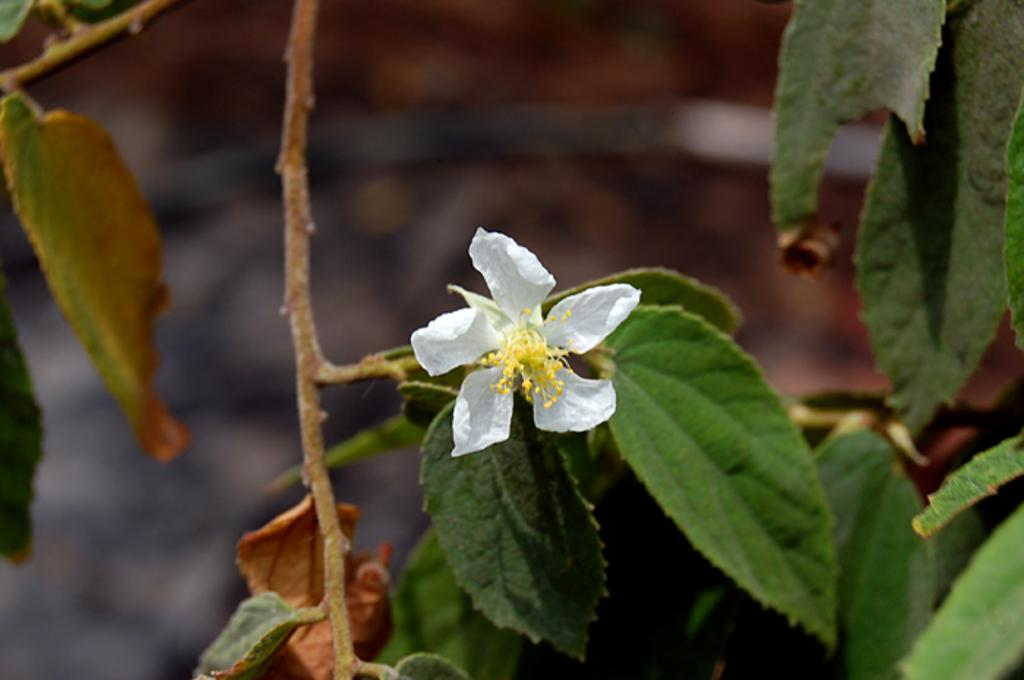What is the main subject in the foreground of the image? There is a flower in the foreground of the image. What is attached to the flower in the foreground? There are leaves on a stem in the foreground of the image. What can be seen in the background of the image? There is a stem in the background of the image. What is attached to the stem in the background? There are leaves on a stem in the background of the image. How many tickets are visible on the hydrant in the image? There is no hydrant present in the image, and therefore no tickets can be observed. Is the person driving in the image? There is no person or vehicle present in the image, so it is impossible to determine if anyone is driving. 